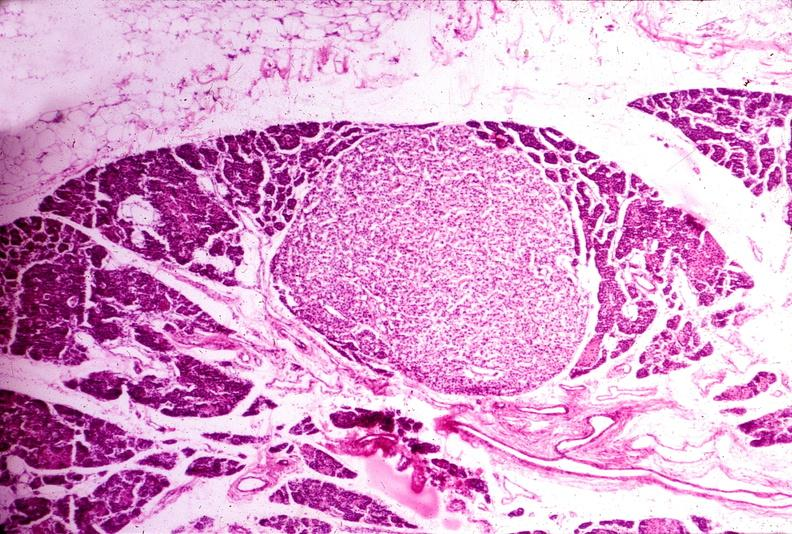does photo show parathyroid adenoma?
Answer the question using a single word or phrase. No 